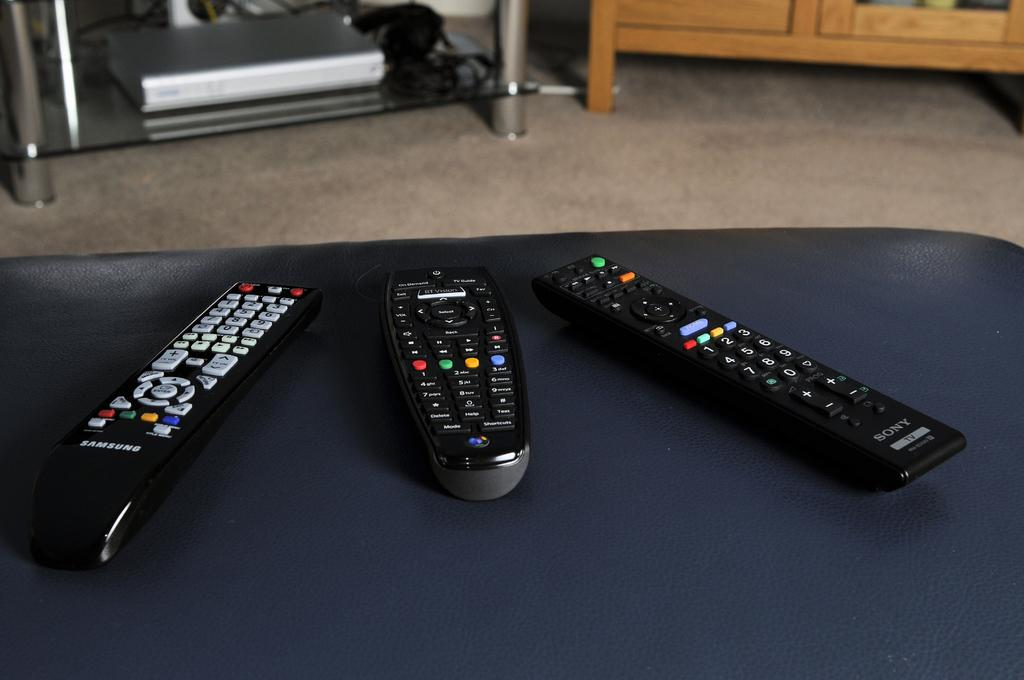<image>
Summarize the visual content of the image. Three remotes and one is a Samsung and one is a Sony. 